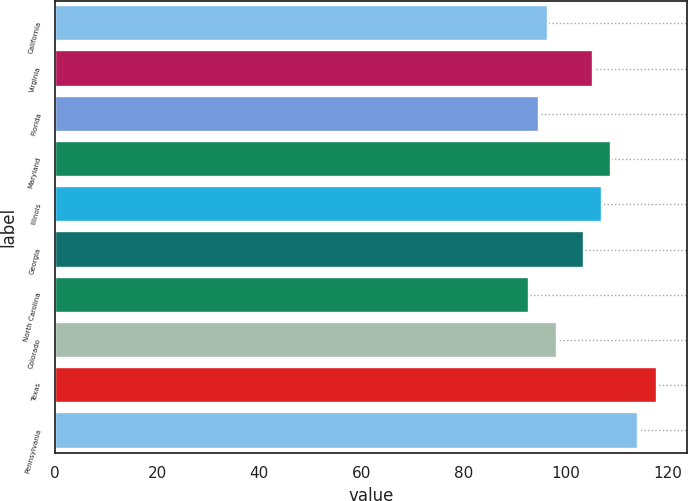Convert chart to OTSL. <chart><loc_0><loc_0><loc_500><loc_500><bar_chart><fcel>California<fcel>Virginia<fcel>Florida<fcel>Maryland<fcel>Illinois<fcel>Georgia<fcel>North Carolina<fcel>Colorado<fcel>Texas<fcel>Pennsylvania<nl><fcel>96.52<fcel>105.42<fcel>94.74<fcel>108.98<fcel>107.2<fcel>103.64<fcel>92.96<fcel>98.3<fcel>117.88<fcel>114.32<nl></chart> 